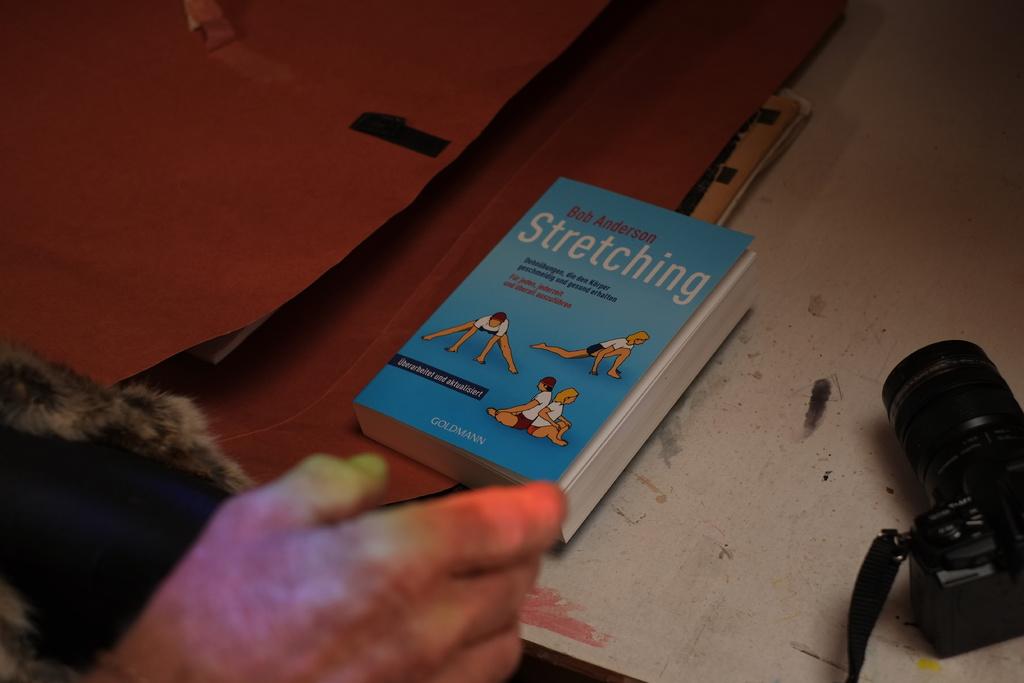Who wrote the book?
Provide a succinct answer. Bob anderson. 